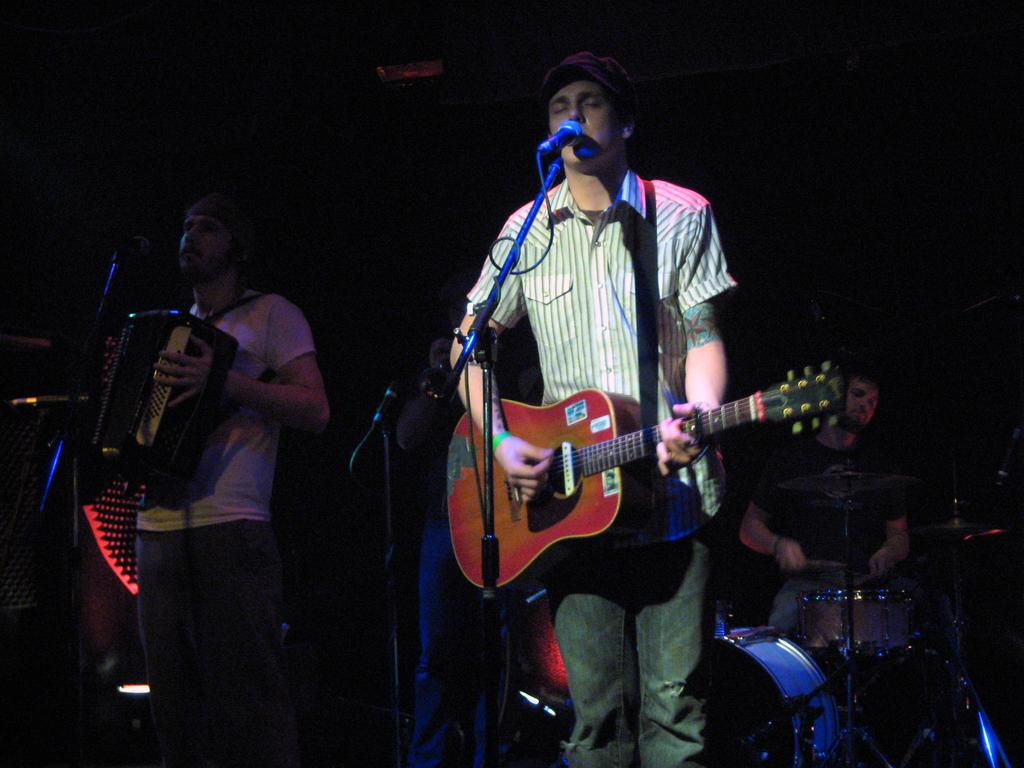What is the person holding in the image? The person is holding a guitar, which is a musical instrument. Can you describe the other musical instrument in the image? There is a mic with a mic holder in the image. What is the person's posture in the image? The person is sitting. What is the person doing with the guitar? The person is playing a musical instrument, specifically the guitar. What position does the robin take in the image? There is no robin present in the image. What is the price of the guitar in the image? The price of the guitar is not visible in the image. 